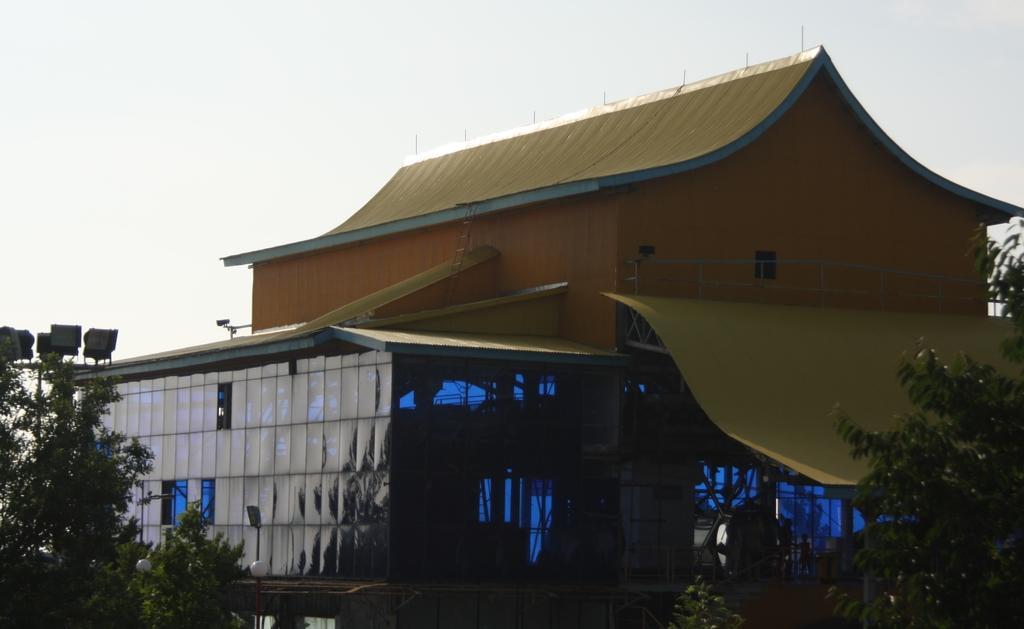Describe this image in one or two sentences. In this image I can see few trees, some water, few buildings which are yellow, orange and black in color and in the background I can see the sky. 